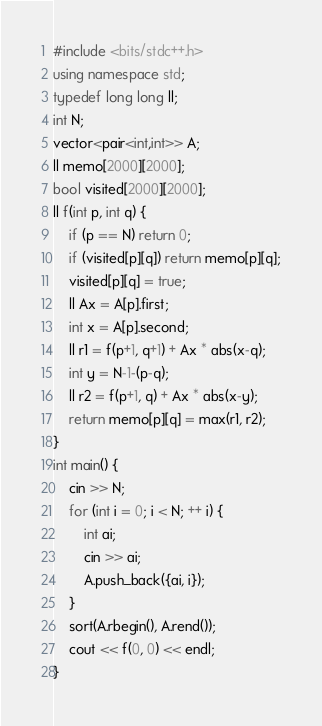Convert code to text. <code><loc_0><loc_0><loc_500><loc_500><_C++_>#include <bits/stdc++.h>
using namespace std;
typedef long long ll;
int N;
vector<pair<int,int>> A;
ll memo[2000][2000];
bool visited[2000][2000];
ll f(int p, int q) {
	if (p == N) return 0;
	if (visited[p][q]) return memo[p][q];
	visited[p][q] = true;
	ll Ax = A[p].first;
	int x = A[p].second;
	ll r1 = f(p+1, q+1) + Ax * abs(x-q);
	int y = N-1-(p-q);
	ll r2 = f(p+1, q) + Ax * abs(x-y);
	return memo[p][q] = max(r1, r2);
}
int main() {
	cin >> N;
	for (int i = 0; i < N; ++ i) {
		int ai;
		cin >> ai;
		A.push_back({ai, i});
	}
	sort(A.rbegin(), A.rend());
	cout << f(0, 0) << endl;
}
</code> 